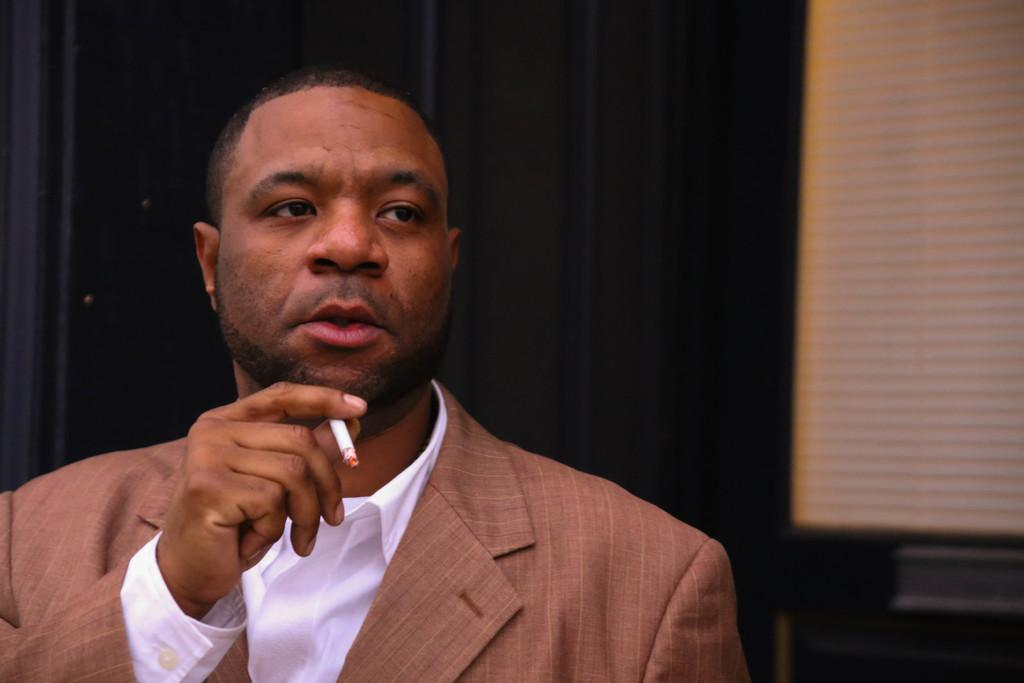Who is present in the image? There is a man in the picture. What is the man holding in his hand? The man is holding a cigarette with his hand. What can be seen behind the man? There is a wall behind the man. How many lizards are crawling on the beds in the image? There are no lizards or beds present in the image. 